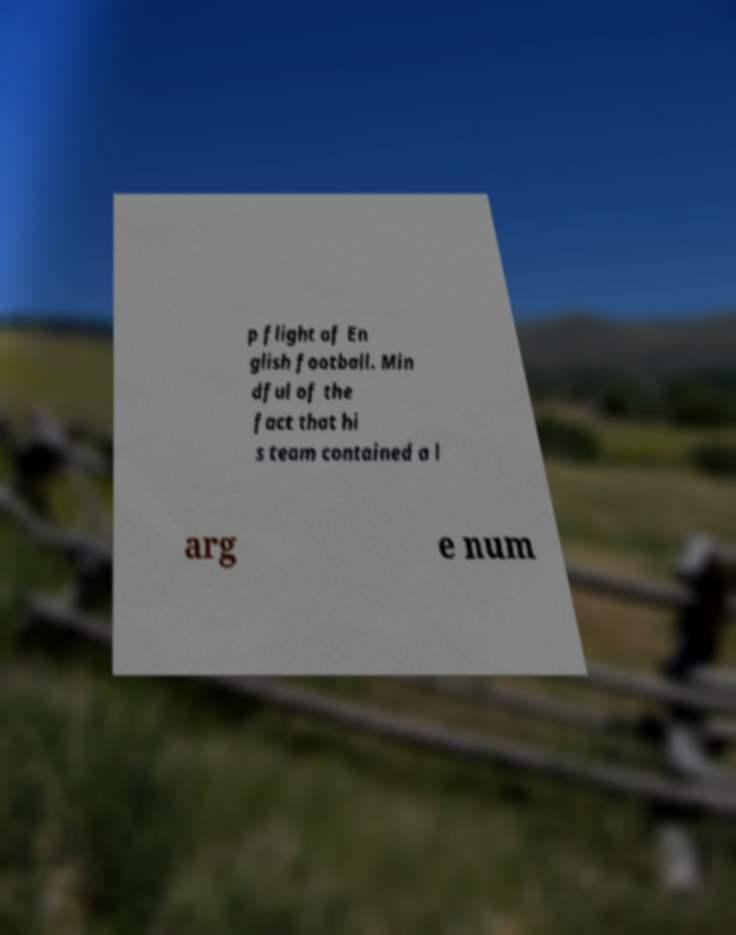Please identify and transcribe the text found in this image. p flight of En glish football. Min dful of the fact that hi s team contained a l arg e num 